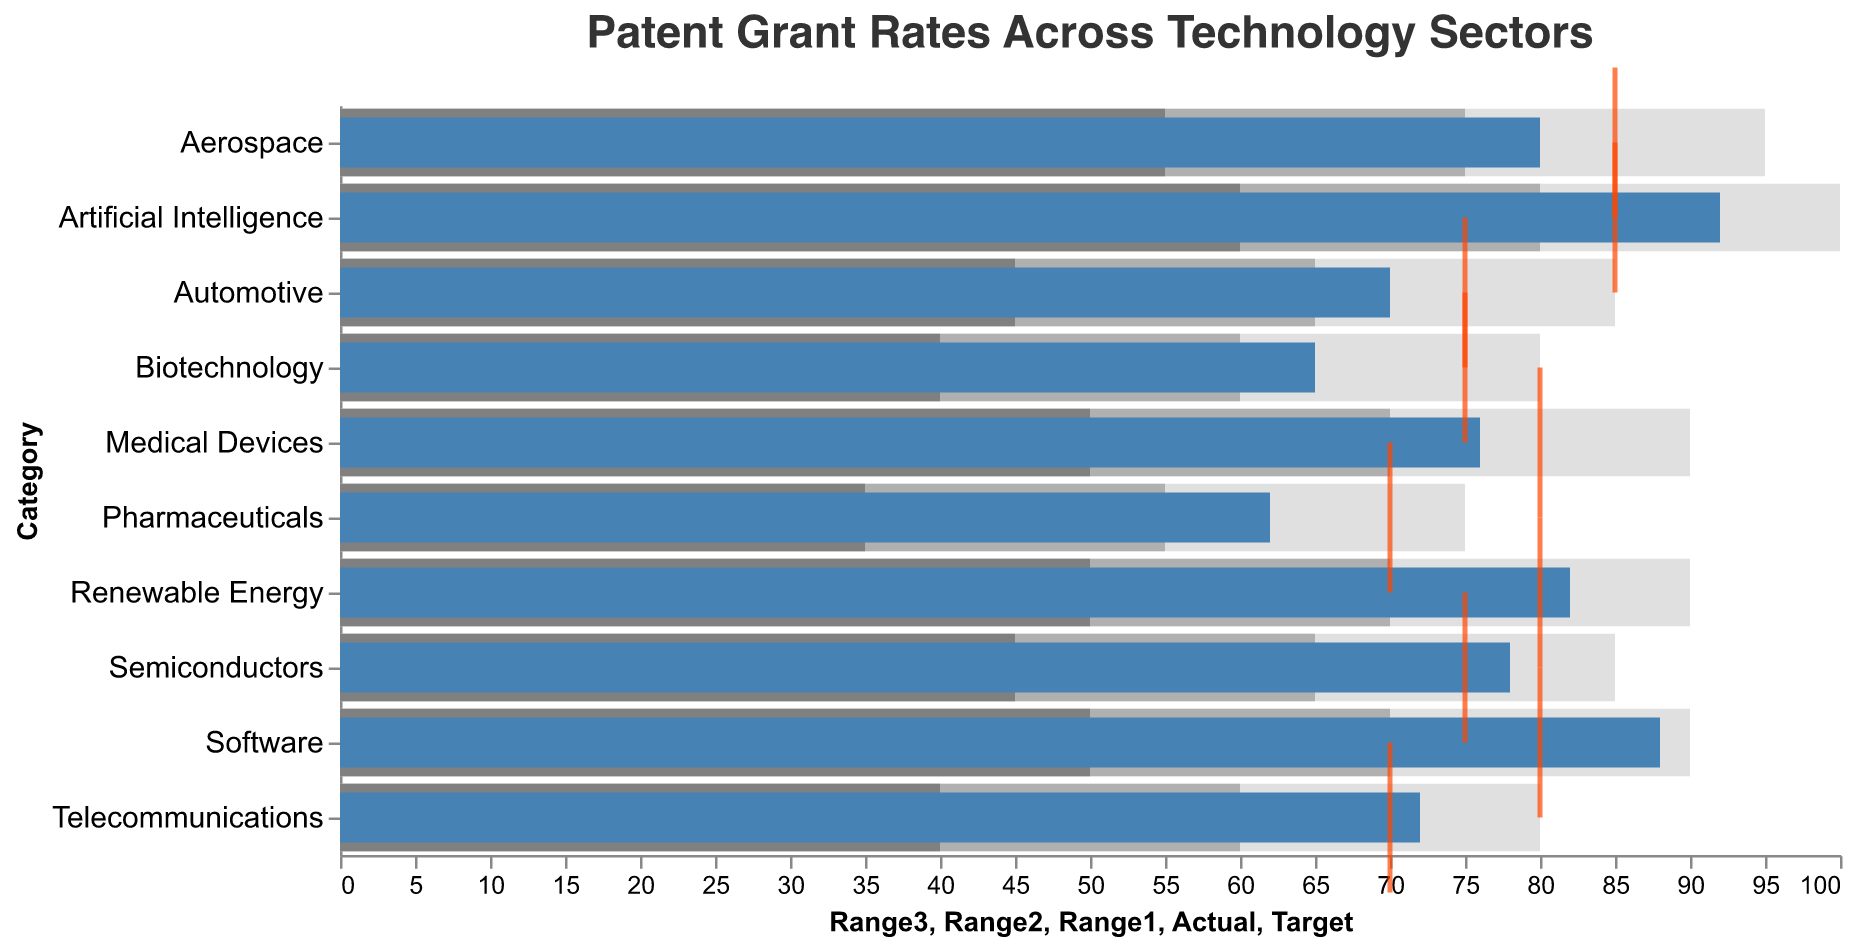What's the title of the figure? The title of the figure is displayed at the top.
Answer: Patent Grant Rates Across Technology Sectors How many technology sectors are displayed in the chart? Count the number of different categories shown on the y-axis. There are 10 technology sectors.
Answer: 10 In which sector is the actual patent grant rate the highest? Look at the blue bars for the highest value. The sector with the highest actual rate is Artificial Intelligence at 92.
Answer: Artificial Intelligence What is the target patent grant rate for the Aerospace sector? Identify the position of the tick mark in the Aerospace row. The target rate is 85.
Answer: 85 Which sector has the largest difference between actual and target patent grant rates? Calculate the difference between actual and target rates for each sector. Artificial Intelligence has the largest difference with an actual rate of 92 and a target of 85, a difference of 7.
Answer: Artificial Intelligence What is the range1 value for the Biotechnology sector and what does it represent? Range1 for Biotechnology is 40. It represents the minimum acceptable level for the patent grant rate.
Answer: 40 Which sector exceeds its target patent grant rate by the greatest margin? Compare the actual rates to the target rates and find the sector with the highest positive difference. Software exceeds its target by 8.
Answer: Software What is the color used to depict the target rates in the chart? The target rates are represented by tick marks which are colored in red.
Answer: red How many sectors have actual patent grant rates above their targets? Count the number of sectors where the blue bar (actual rate) exceeds the red tick mark (target rate). There are 6 sectors: Software, Telecommunications, Semiconductors, Renewable Energy, Medical Devices, and Artificial Intelligence.
Answer: 6 